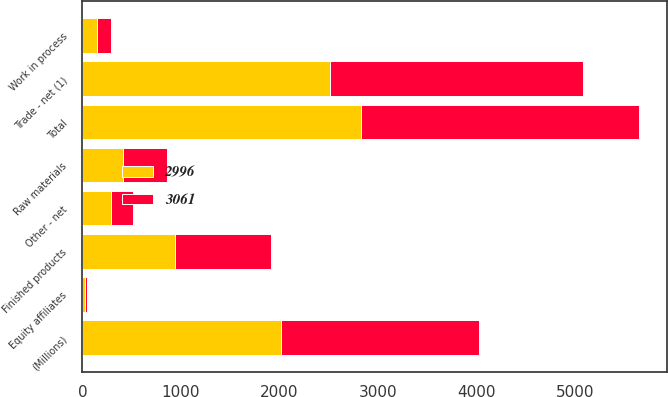Convert chart. <chart><loc_0><loc_0><loc_500><loc_500><stacked_bar_chart><ecel><fcel>(Millions)<fcel>Trade - net (1)<fcel>Equity affiliates<fcel>Other - net<fcel>Total<fcel>Finished products<fcel>Work in process<fcel>Raw materials<nl><fcel>3061<fcel>2012<fcel>2568<fcel>22<fcel>223<fcel>2813<fcel>980<fcel>144<fcel>443<nl><fcel>2996<fcel>2011<fcel>2512<fcel>28<fcel>290<fcel>2830<fcel>935<fcel>144<fcel>414<nl></chart> 